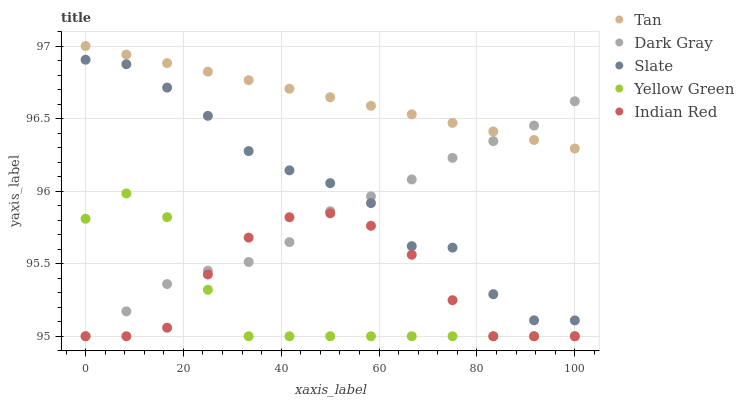Does Yellow Green have the minimum area under the curve?
Answer yes or no. Yes. Does Tan have the maximum area under the curve?
Answer yes or no. Yes. Does Slate have the minimum area under the curve?
Answer yes or no. No. Does Slate have the maximum area under the curve?
Answer yes or no. No. Is Tan the smoothest?
Answer yes or no. Yes. Is Slate the roughest?
Answer yes or no. Yes. Is Slate the smoothest?
Answer yes or no. No. Is Tan the roughest?
Answer yes or no. No. Does Dark Gray have the lowest value?
Answer yes or no. Yes. Does Slate have the lowest value?
Answer yes or no. No. Does Tan have the highest value?
Answer yes or no. Yes. Does Slate have the highest value?
Answer yes or no. No. Is Yellow Green less than Tan?
Answer yes or no. Yes. Is Tan greater than Slate?
Answer yes or no. Yes. Does Indian Red intersect Dark Gray?
Answer yes or no. Yes. Is Indian Red less than Dark Gray?
Answer yes or no. No. Is Indian Red greater than Dark Gray?
Answer yes or no. No. Does Yellow Green intersect Tan?
Answer yes or no. No. 